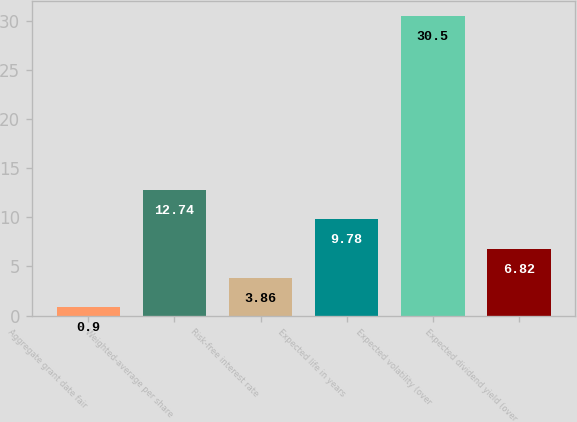Convert chart to OTSL. <chart><loc_0><loc_0><loc_500><loc_500><bar_chart><fcel>Aggregate grant date fair<fcel>Weighted-average per share<fcel>Risk-free interest rate<fcel>Expected life in years<fcel>Expected volatility (over<fcel>Expected dividend yield (over<nl><fcel>0.9<fcel>12.74<fcel>3.86<fcel>9.78<fcel>30.5<fcel>6.82<nl></chart> 